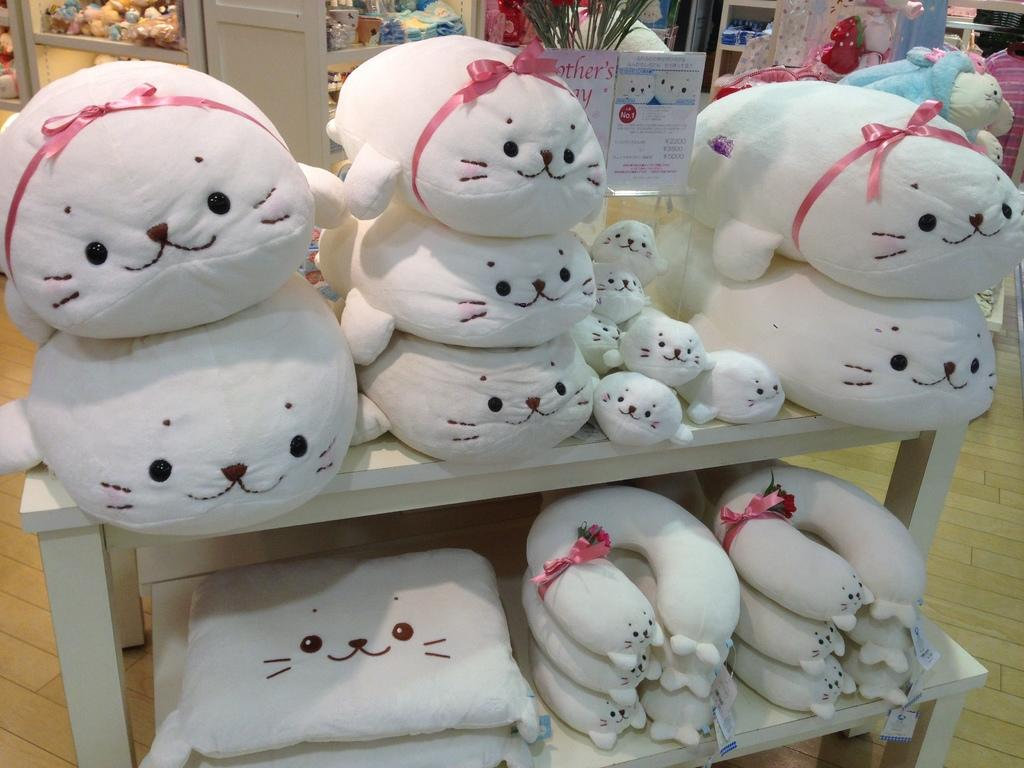What types of items can be seen on the shelves in the image? There are toys and neck pillows on the shelves in the image. What can be seen in the background of the image? There are doors, additional toys, a greeting card, and a plant visible in the background. What type of map is hanging on the wall in the image? There is no map present in the image. What type of frame is around the vacation photo in the image? There is no vacation photo or frame present in the image. 